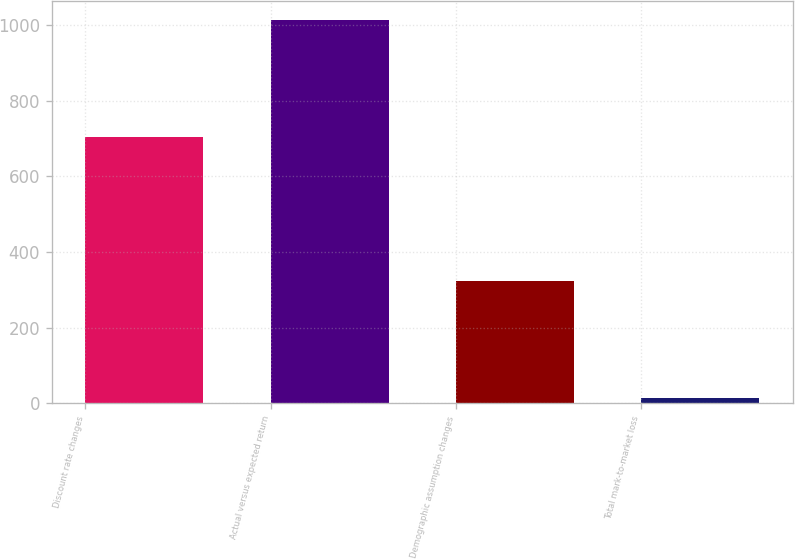Convert chart to OTSL. <chart><loc_0><loc_0><loc_500><loc_500><bar_chart><fcel>Discount rate changes<fcel>Actual versus expected return<fcel>Demographic assumption changes<fcel>Total mark-to-market loss<nl><fcel>705<fcel>1013<fcel>323<fcel>15<nl></chart> 